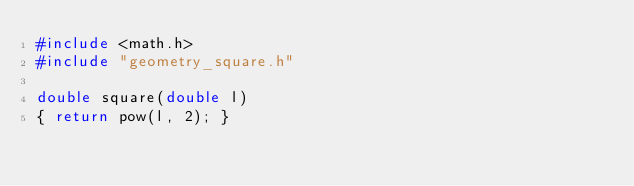Convert code to text. <code><loc_0><loc_0><loc_500><loc_500><_C_>#include <math.h>
#include "geometry_square.h"

double square(double l) 
{ return pow(l, 2); }
</code> 